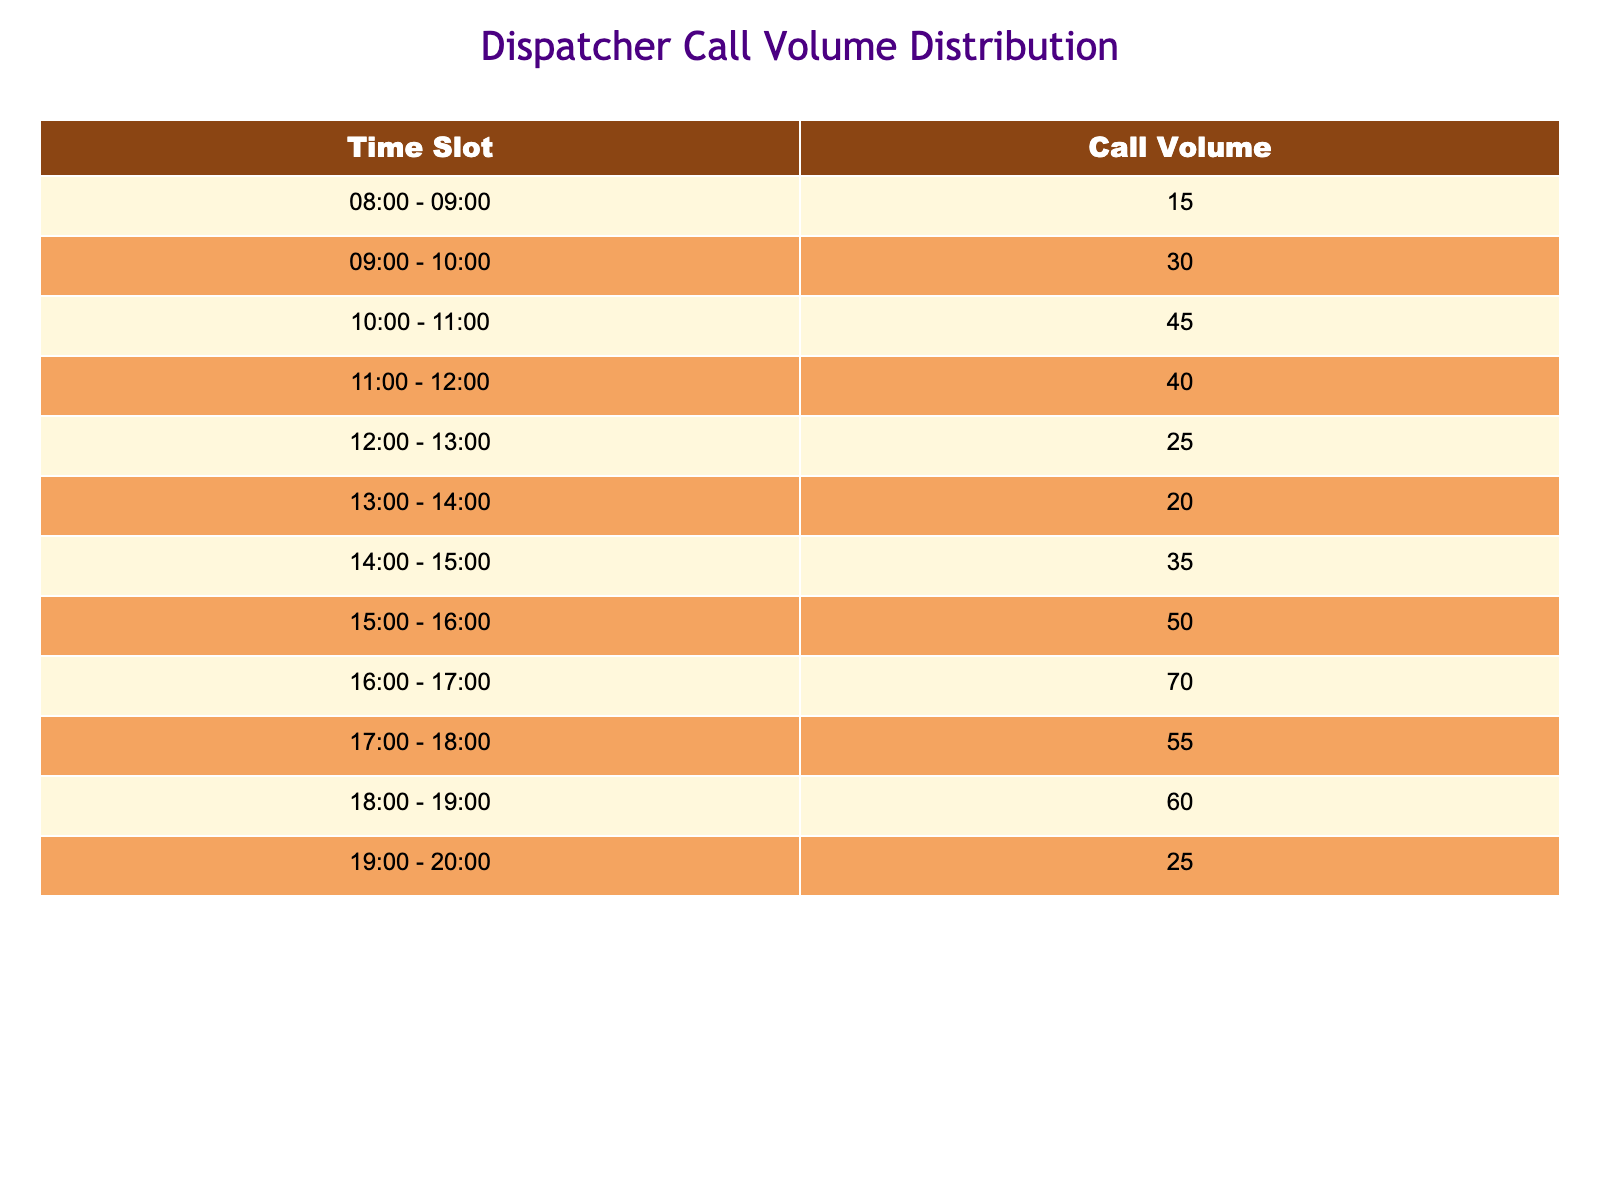What is the call volume during the time slot from 15:00 to 16:00? Referring to the table, the call volume for the time slot from 15:00 to 16:00 is listed directly in the table as 50.
Answer: 50 What is the total call volume received from 08:00 to 12:00? To find the total call volume from 08:00 to 12:00, we sum the call volumes from each of the respective time slots: 15 (08:00-09:00) + 30 (09:00-10:00) + 45 (10:00-11:00) + 40 (11:00-12:00) = 15 + 30 + 45 + 40 = 130.
Answer: 130 Is the call volume higher during 17:00 - 18:00 compared to 14:00 - 15:00? The call volume for 17:00 - 18:00 is listed as 55, while for 14:00 - 15:00 it is 35. Since 55 is greater than 35, the answer is yes.
Answer: Yes What is the average call volume across all time slots? To find the average, first sum all the call volumes: 15 + 30 + 45 + 40 + 25 + 20 + 35 + 50 + 70 + 55 + 60 + 25 =  455. There are 12 time slots, so we calculate the average as 455 / 12 = approximately 37.92.
Answer: Approximately 37.92 Which time slot has the highest call volume? By examining the call volumes in the table, the highest value is 70, which falls within the time slot of 16:00 - 17:00.
Answer: 16:00 - 17:00 What is the total call volume received from 18:00 to 20:00? We need to sum the call volumes for the slots 18:00 - 19:00 (60) and 19:00 - 20:00 (25). Adding them gives us 60 + 25 = 85.
Answer: 85 Is 12:00 - 13:00 the time slot with the lowest call volume? The call volume for 12:00 - 13:00 is 25. Checking other time slots reveals that 08:00 - 09:00 has the lowest at 15. Therefore, the answer is no.
Answer: No What is the difference in call volume between slots 10:00 - 11:00 and 18:00 - 19:00? The call volume for 10:00 - 11:00 is 45, and for 18:00 - 19:00 it is 60. The difference is calculated as 60 - 45 = 15.
Answer: 15 